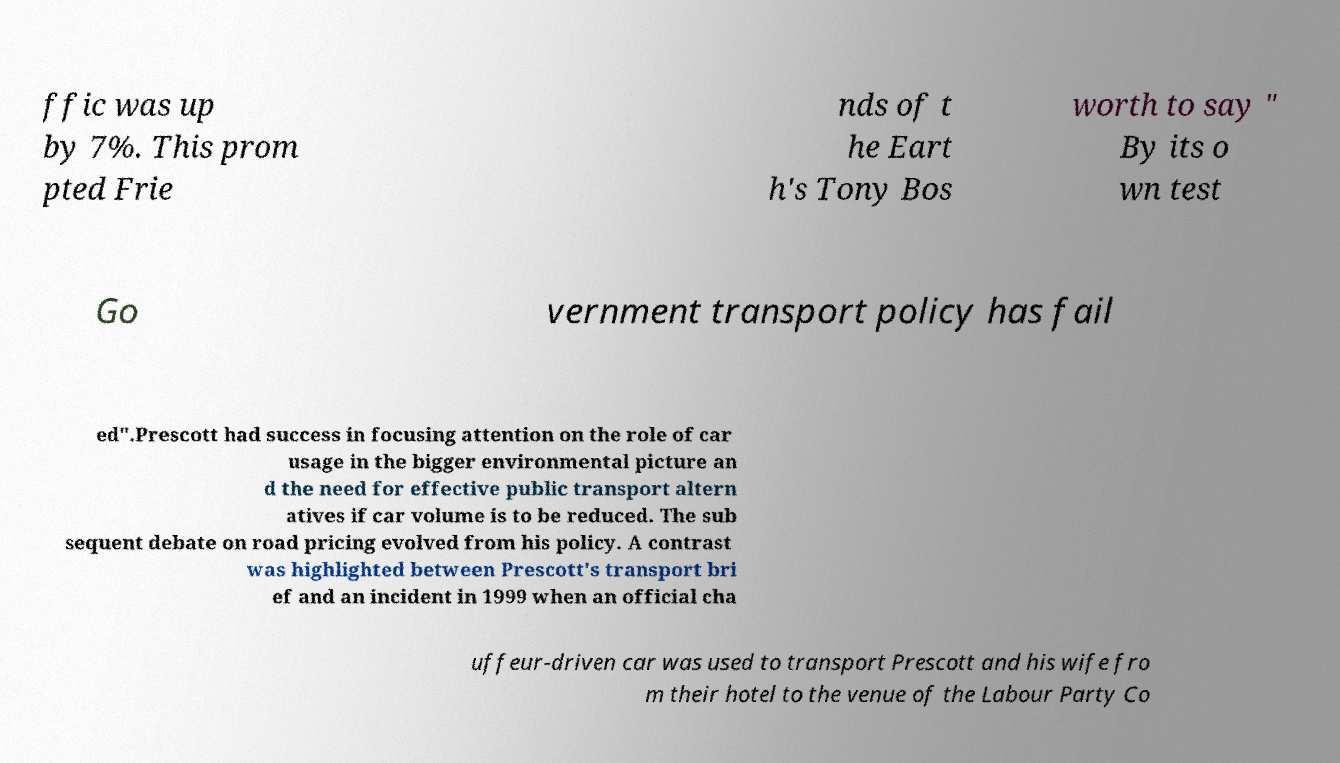For documentation purposes, I need the text within this image transcribed. Could you provide that? ffic was up by 7%. This prom pted Frie nds of t he Eart h's Tony Bos worth to say " By its o wn test Go vernment transport policy has fail ed".Prescott had success in focusing attention on the role of car usage in the bigger environmental picture an d the need for effective public transport altern atives if car volume is to be reduced. The sub sequent debate on road pricing evolved from his policy. A contrast was highlighted between Prescott's transport bri ef and an incident in 1999 when an official cha uffeur-driven car was used to transport Prescott and his wife fro m their hotel to the venue of the Labour Party Co 